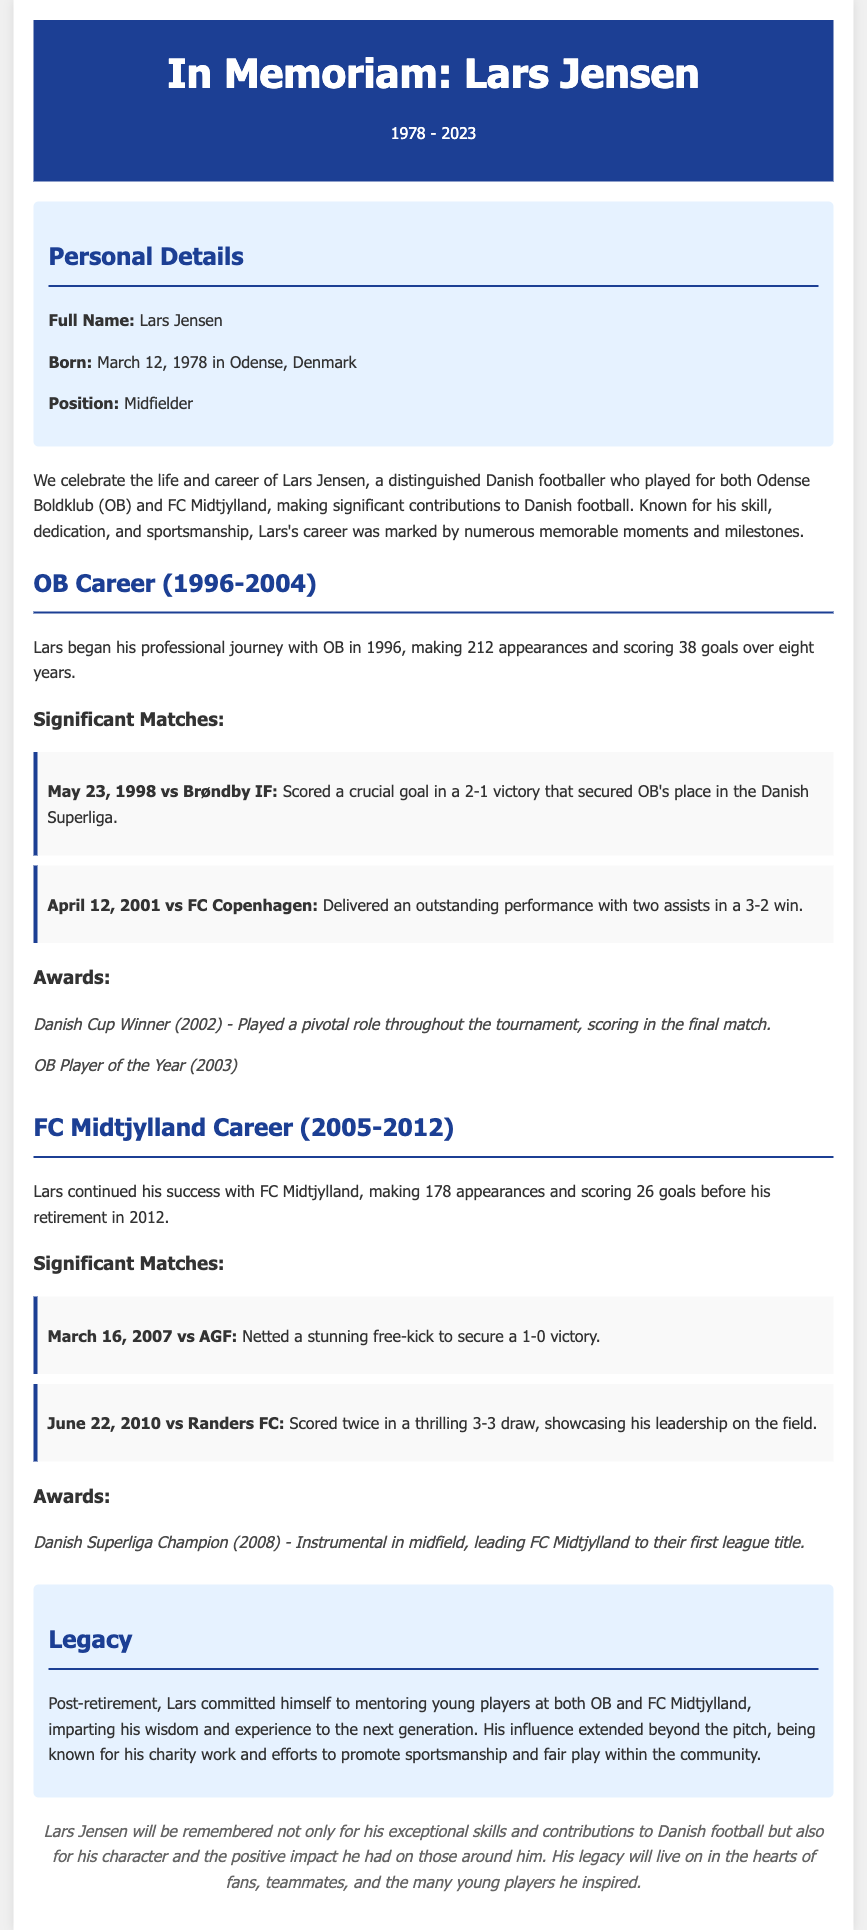What is Lars Jensen's birth date? Lars Jensen was born on March 12, 1978.
Answer: March 12, 1978 How many appearances did Lars make for OB? The document states that Lars made 212 appearances for OB.
Answer: 212 What year did Lars win the Danish Cup? According to the document, Lars won the Danish Cup in 2002.
Answer: 2002 Which team did Lars help to win their first Danish Superliga title? Lars played a pivotal role in FC Midtjylland winning their first league title.
Answer: FC Midtjylland How many goals did Lars score for FC Midtjylland? The document mentions that Lars scored 26 goals for FC Midtjylland.
Answer: 26 What significant event happened on May 23, 1998? On that date, Lars scored a crucial goal securing OB's place in the Superliga.
Answer: Scored a crucial goal What role did Lars take on post-retirement? After retiring, Lars committed to mentoring young players.
Answer: Mentoring young players How many years did Lars play for OB? The document indicates Lars played for OB for eight years.
Answer: Eight years What was Lars's position in football? The document states that Lars played as a midfielder.
Answer: Midfielder 